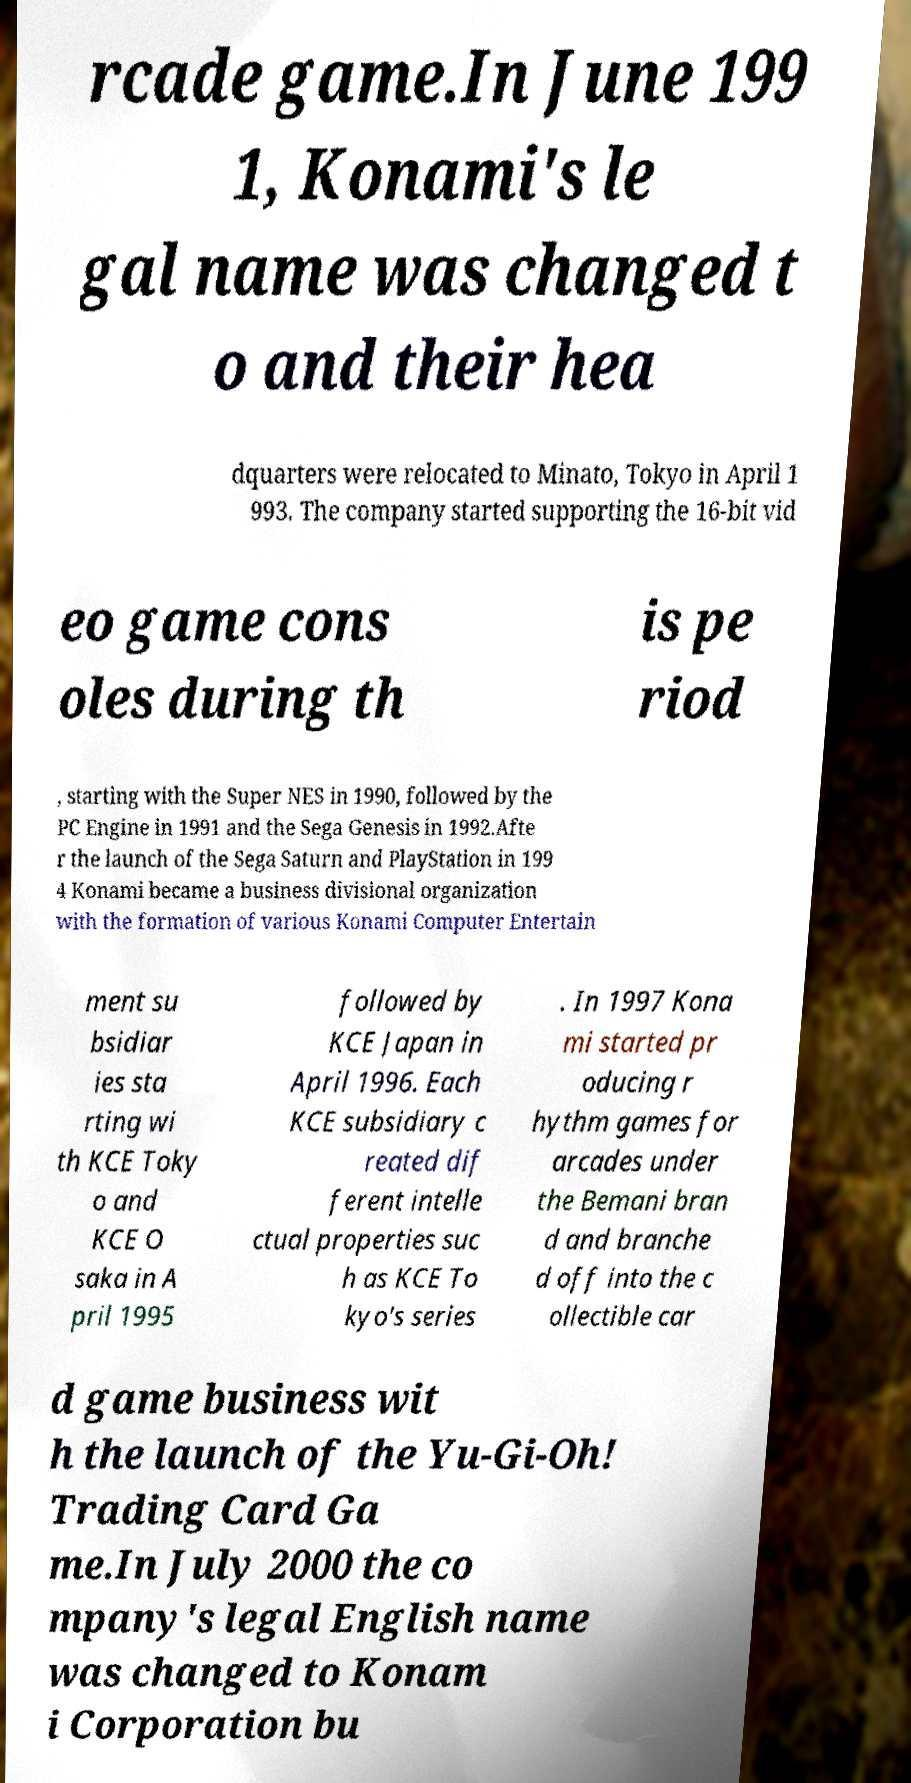Could you extract and type out the text from this image? rcade game.In June 199 1, Konami's le gal name was changed t o and their hea dquarters were relocated to Minato, Tokyo in April 1 993. The company started supporting the 16-bit vid eo game cons oles during th is pe riod , starting with the Super NES in 1990, followed by the PC Engine in 1991 and the Sega Genesis in 1992.Afte r the launch of the Sega Saturn and PlayStation in 199 4 Konami became a business divisional organization with the formation of various Konami Computer Entertain ment su bsidiar ies sta rting wi th KCE Toky o and KCE O saka in A pril 1995 followed by KCE Japan in April 1996. Each KCE subsidiary c reated dif ferent intelle ctual properties suc h as KCE To kyo's series . In 1997 Kona mi started pr oducing r hythm games for arcades under the Bemani bran d and branche d off into the c ollectible car d game business wit h the launch of the Yu-Gi-Oh! Trading Card Ga me.In July 2000 the co mpany's legal English name was changed to Konam i Corporation bu 